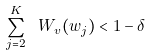<formula> <loc_0><loc_0><loc_500><loc_500>\sum _ { j = 2 } ^ { K } \ W _ { v } ( w _ { j } ) < 1 - \delta</formula> 